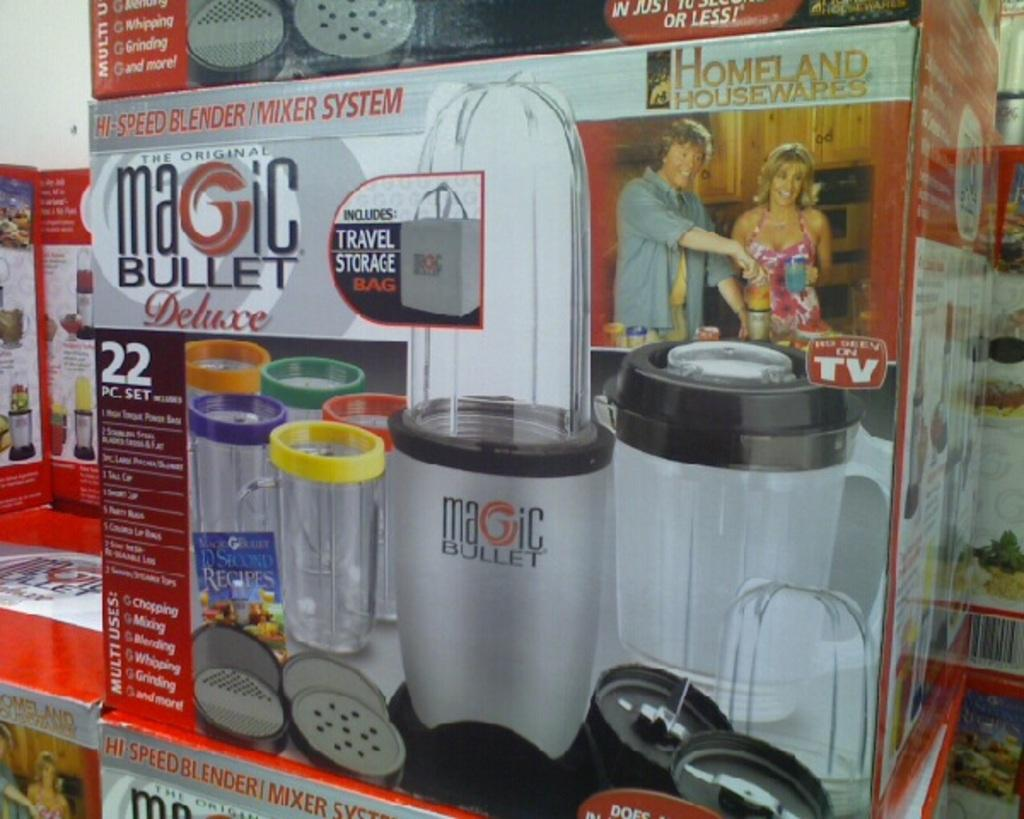<image>
Render a clear and concise summary of the photo. The name of this blender is called the "Magic Bullet." 